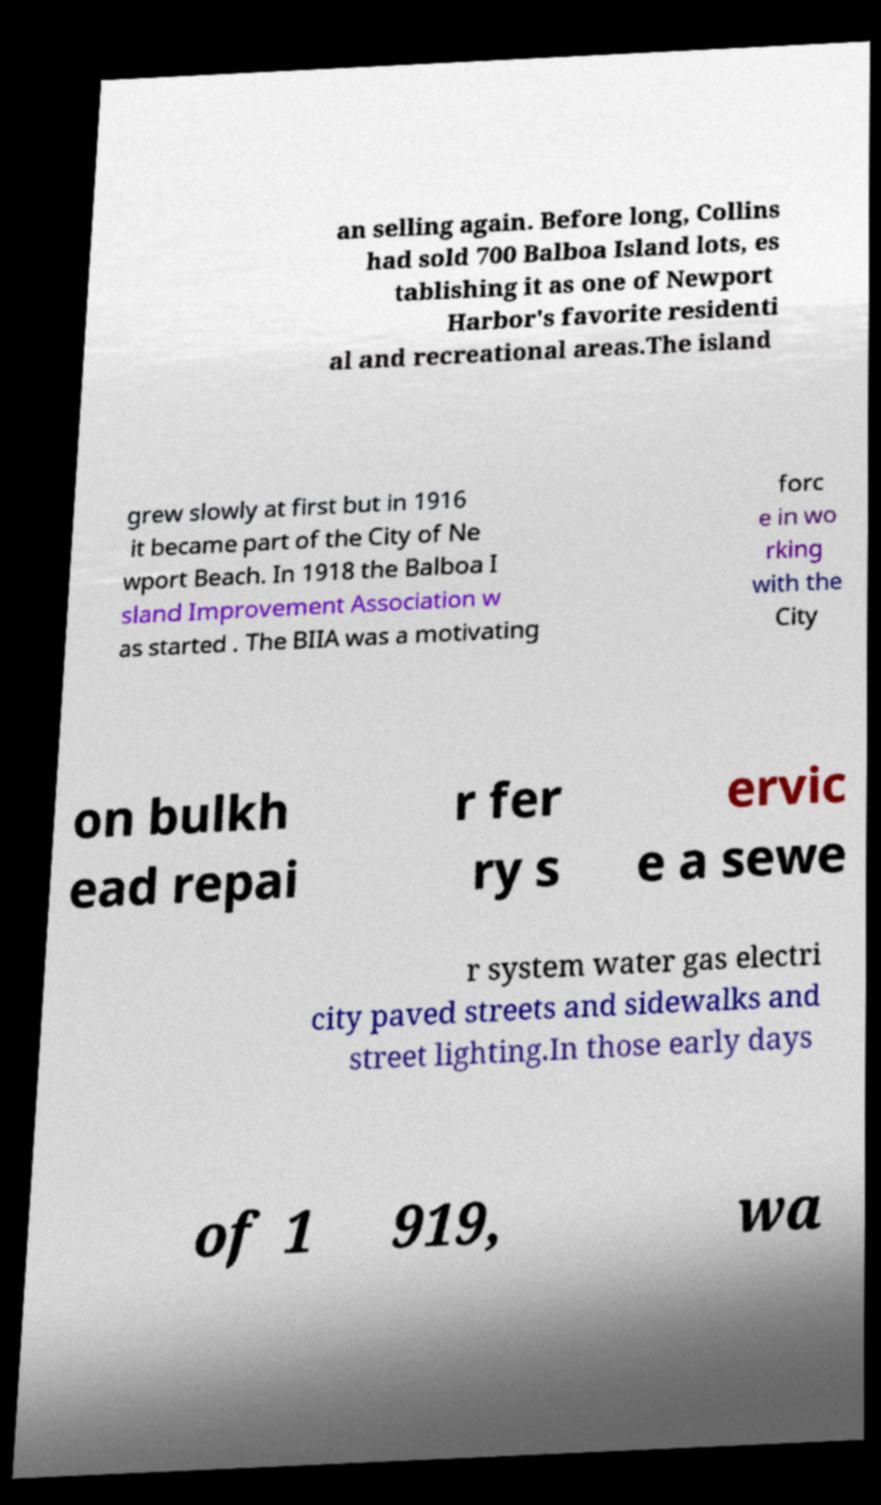What messages or text are displayed in this image? I need them in a readable, typed format. an selling again. Before long, Collins had sold 700 Balboa Island lots, es tablishing it as one of Newport Harbor's favorite residenti al and recreational areas.The island grew slowly at first but in 1916 it became part of the City of Ne wport Beach. In 1918 the Balboa I sland Improvement Association w as started . The BIIA was a motivating forc e in wo rking with the City on bulkh ead repai r fer ry s ervic e a sewe r system water gas electri city paved streets and sidewalks and street lighting.In those early days of 1 919, wa 